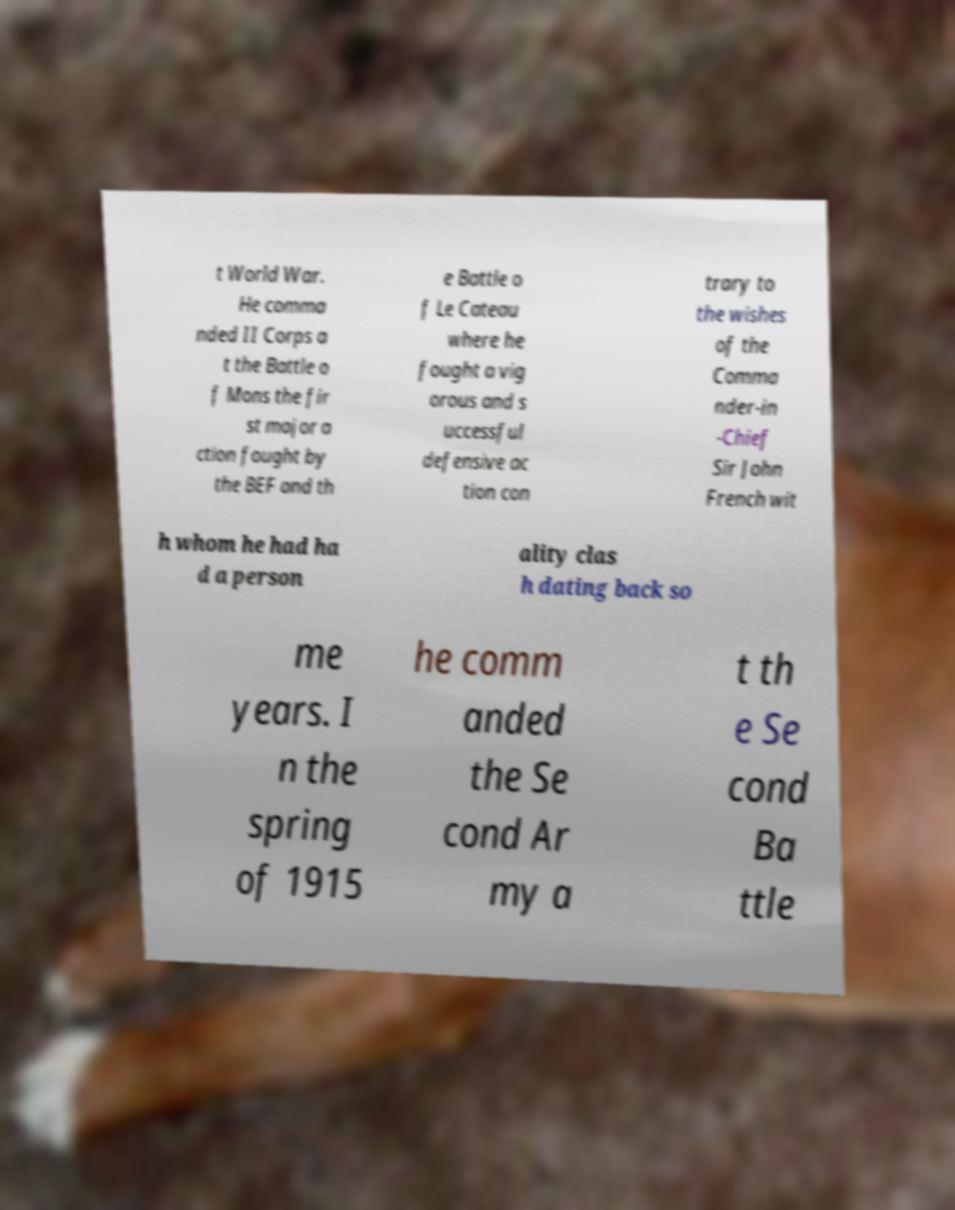Could you assist in decoding the text presented in this image and type it out clearly? t World War. He comma nded II Corps a t the Battle o f Mons the fir st major a ction fought by the BEF and th e Battle o f Le Cateau where he fought a vig orous and s uccessful defensive ac tion con trary to the wishes of the Comma nder-in -Chief Sir John French wit h whom he had ha d a person ality clas h dating back so me years. I n the spring of 1915 he comm anded the Se cond Ar my a t th e Se cond Ba ttle 